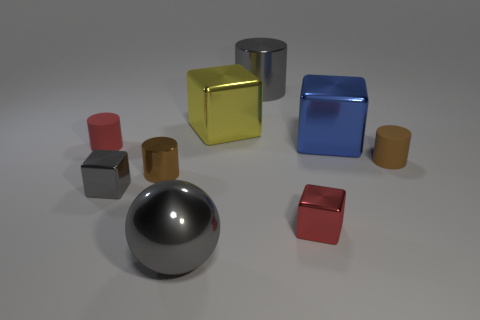Subtract all balls. How many objects are left? 8 Add 3 yellow metallic blocks. How many yellow metallic blocks exist? 4 Subtract 1 gray balls. How many objects are left? 8 Subtract all red blocks. Subtract all big yellow blocks. How many objects are left? 7 Add 4 big blocks. How many big blocks are left? 6 